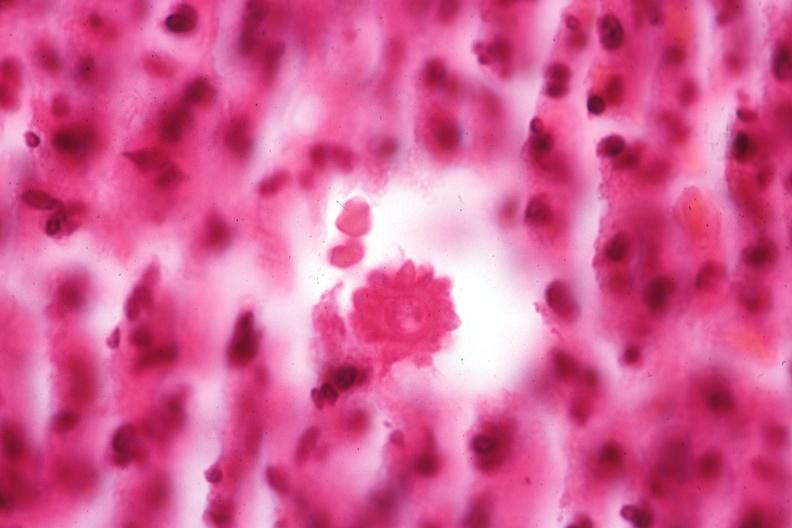s this good yellow color slide present?
Answer the question using a single word or phrase. No 